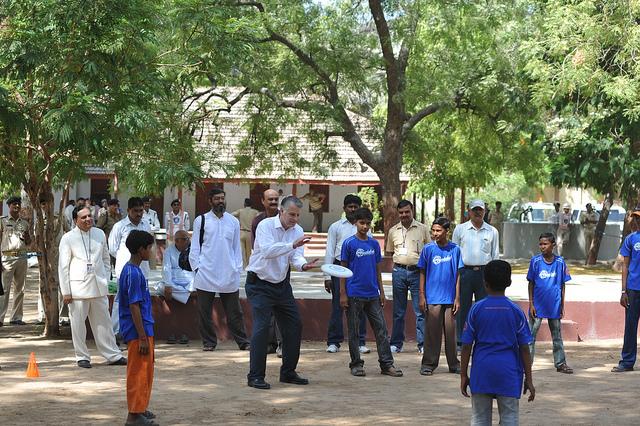What is the man doing in the picture?
Keep it brief. Catching frisbee. What is the man holding?
Concise answer only. Frisbee. How many boys have on blue shirts?
Answer briefly. 6. What toys are these children holding?
Write a very short answer. Frisbee. Are the children related?
Concise answer only. No. 